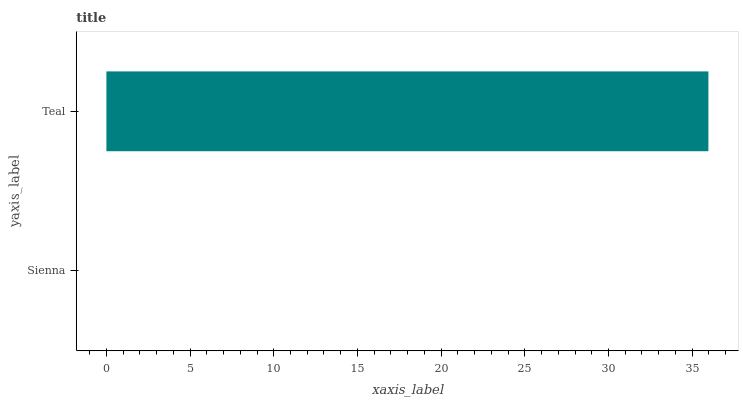Is Sienna the minimum?
Answer yes or no. Yes. Is Teal the maximum?
Answer yes or no. Yes. Is Teal the minimum?
Answer yes or no. No. Is Teal greater than Sienna?
Answer yes or no. Yes. Is Sienna less than Teal?
Answer yes or no. Yes. Is Sienna greater than Teal?
Answer yes or no. No. Is Teal less than Sienna?
Answer yes or no. No. Is Teal the high median?
Answer yes or no. Yes. Is Sienna the low median?
Answer yes or no. Yes. Is Sienna the high median?
Answer yes or no. No. Is Teal the low median?
Answer yes or no. No. 